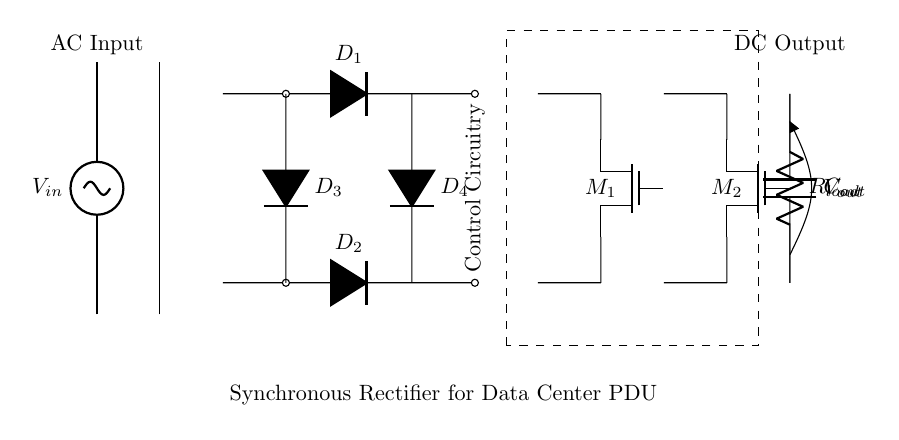What is the type of input voltage for this circuit? The circuit has an AC input indicated by the label $V_{in}$, which signifies that the voltage is alternating current, typically represented as a sine wave.
Answer: AC What is the purpose of the components labeled $D_1$, $D_2$, $D_3$, and $D_4$? These components are labeled as diodes (D), which indicate they are part of a bridge rectifier configuration that allows current to pass in one direction, converting AC current to DC.
Answer: Bridge rectification What is the significance of the synchronous MOSFETs $M_1$ and $M_2$? The synchronous MOSFETs are used for rectification instead of traditional diodes to reduce voltage drop and improve efficiency, particularly important in data center applications where efficiency is critical.
Answer: Improve efficiency What does the dashed rectangle labeled 'Control Circuitry' indicate? This dashed line signifies that there is control circuitry that manages the operation of the synchronous rectifiers, ensuring they function correctly with the input and output load requirements.
Answer: Control management What is the value of the output voltage represented by $V_{out}$? The circuit diagram does not specify a numerical value for $V_{out}$, but it is understood that it should be the DC output resulting from the rectification process.
Answer: Undetermined What is the load indicated by $R_{load}$? $R_{load}$ refers to the resistive load that the output voltage will drive, showing that the circuit is designed to supply power to an external component or system.
Answer: Resistor load What type of capacitor is referred to as $C_{out}$ in the circuit? $C_{out}$ represents the output capacitor that filters the rectified voltage, smoothing out ripples to provide a more stable DC voltage for the load.
Answer: Output smoothing capacitor 